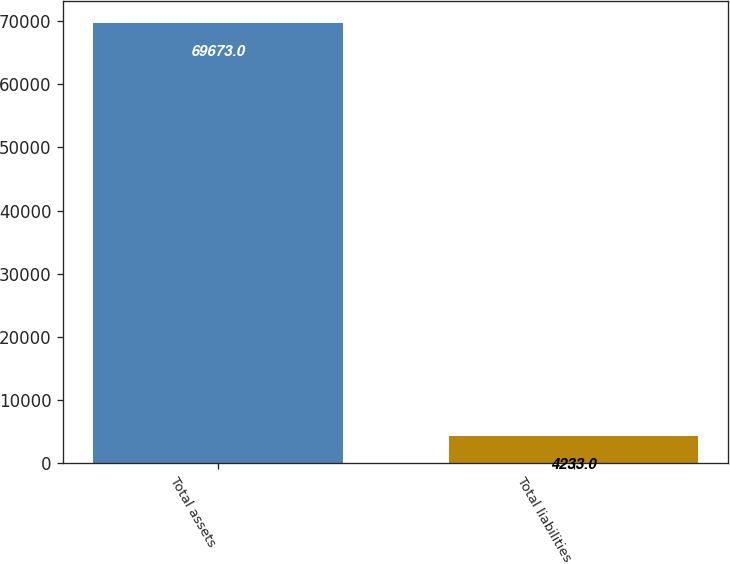Convert chart. <chart><loc_0><loc_0><loc_500><loc_500><bar_chart><fcel>Total assets<fcel>Total liabilities<nl><fcel>69673<fcel>4233<nl></chart> 